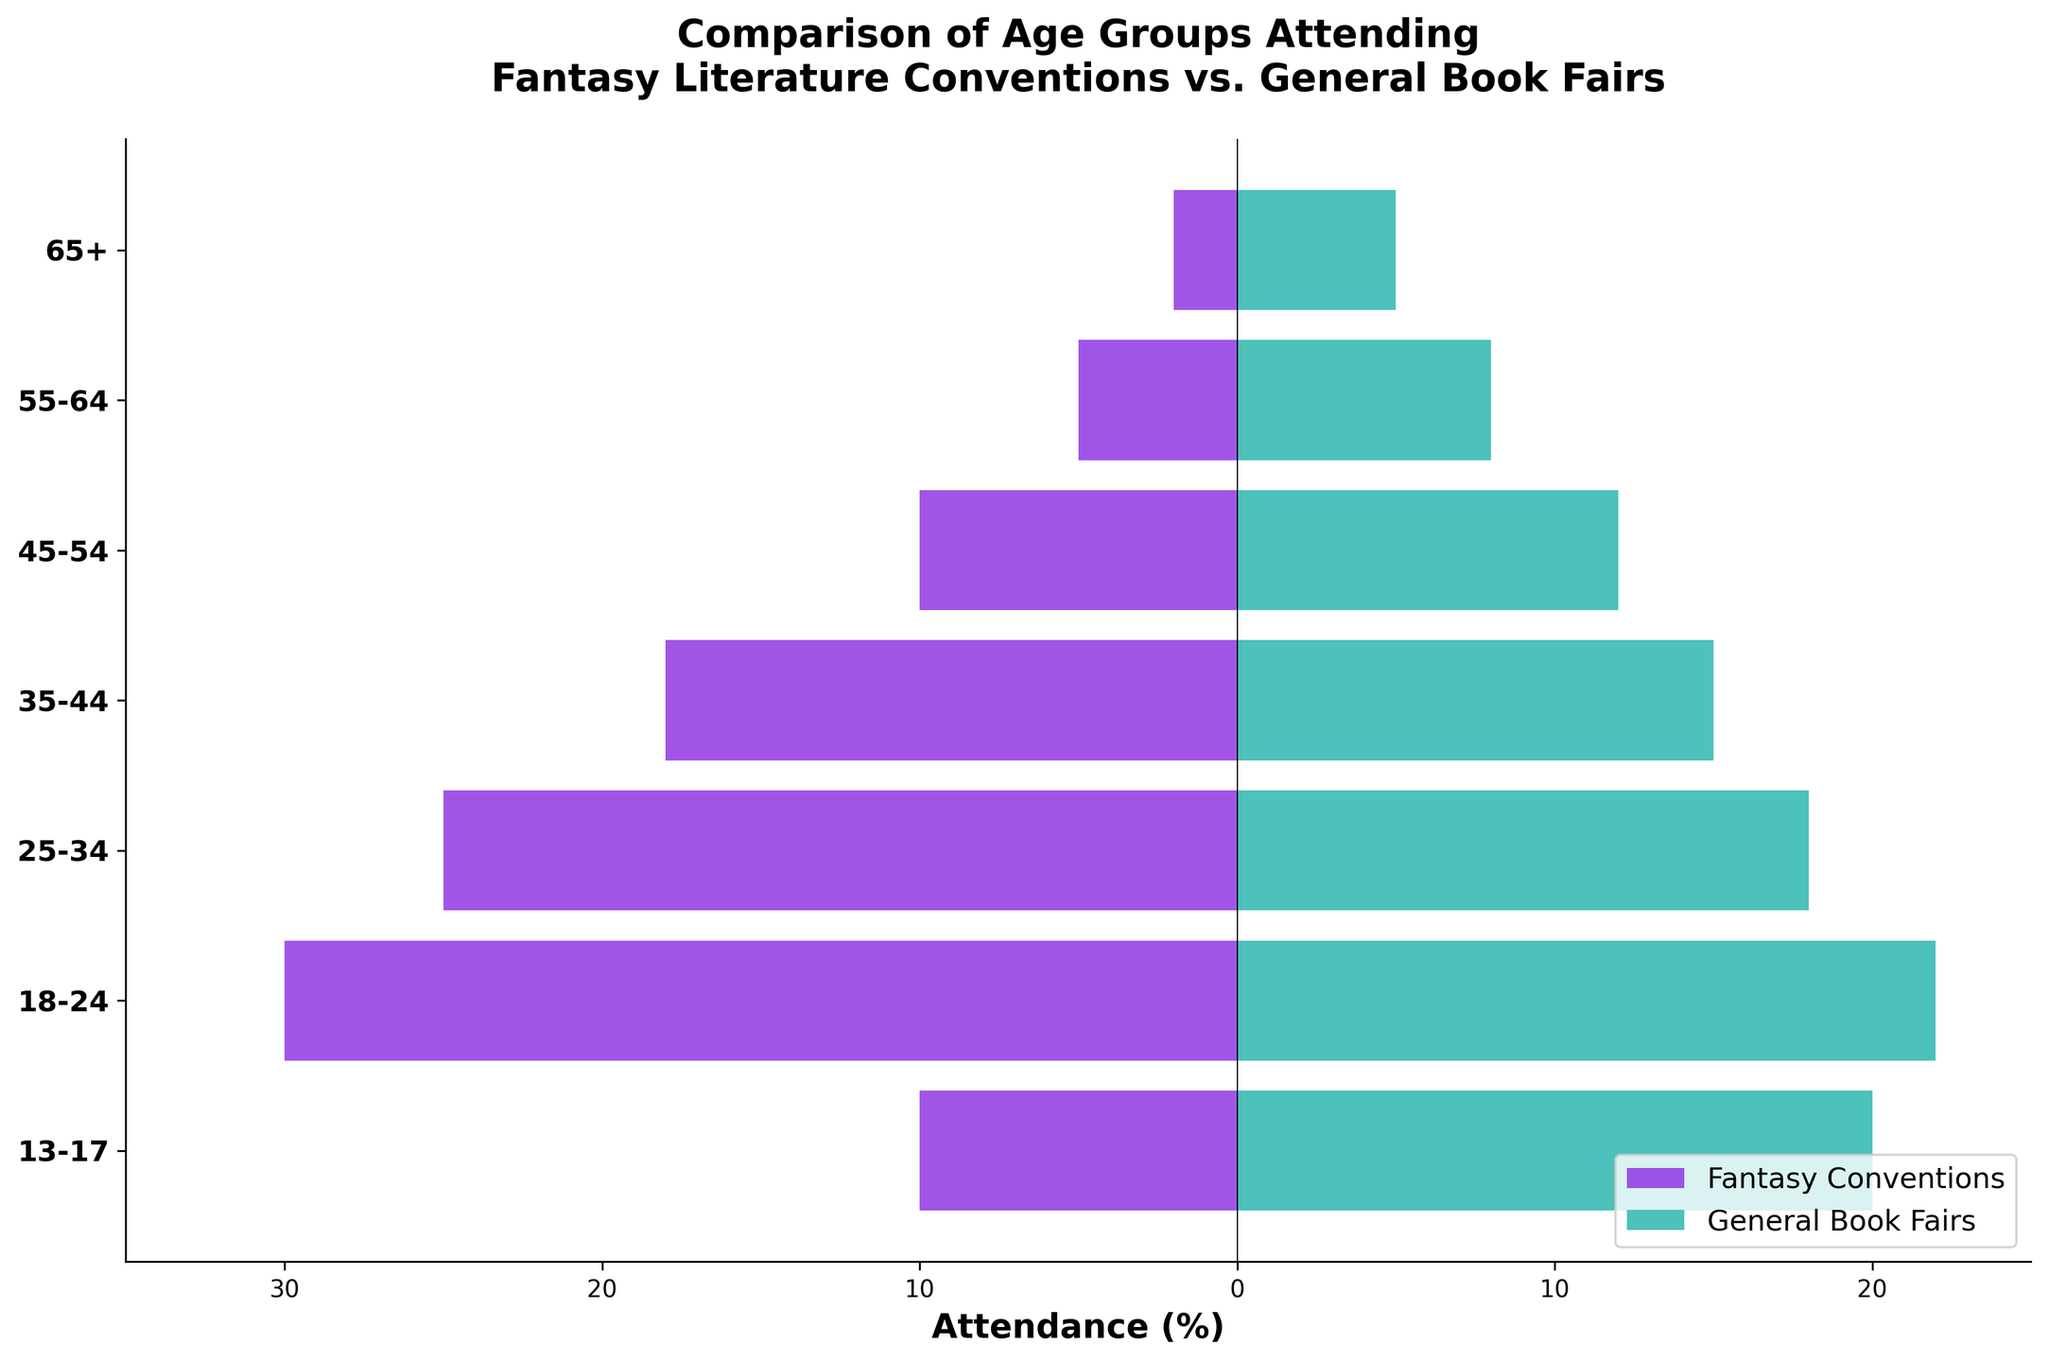What is the title of the figure? The title of the figure is located at the top and is bold. It is "Comparison of Age Groups Attending Fantasy Literature Conventions vs. General Book Fairs".
Answer: Comparison of Age Groups Attending Fantasy Literature Conventions vs. General Book Fairs Which age group has the highest attendance percentage at fantasy conventions? By looking at the bars in the figure, the largest negative value on the fantasy conventions side (purple bars) is for the 18-24 age group.
Answer: 18-24 What is the attendance percentage for the 13-17 age group at general book fairs? Look at the bar corresponding to the 13-17 age group and check the value for the general book fairs side (teal bars). The number is 20.
Answer: 20 Which age group shows the highest attendance for general book fairs? Find the bar with the largest positive value on the general book fairs side (teal bars). The highest value is for the 18-24 age group.
Answer: 18-24 How much higher is the attendance percentage for the 35-44 age group at general book fairs compared to fantasy conventions? The bar for the 35-44 age group shows -18 for fantasy conventions and 15 for general book fairs. The difference is 15 - (-18) = 33.
Answer: 33 Which event has a higher attendance in the 65+ age group, and by how much? Compare the values of the 65+ age group for both events. Fantasy conventions have -2, and general book fairs have 5. General book fairs have a higher attendance by 5 - (-2) = 7.
Answer: General book fairs by 7 What is the range of the x-axis in the figure? The x-axis of the figure ranges from -35 to 25, as seen from the labels and the axis limits.
Answer: -35 to 25 Calculate the total difference in attendance percentages between the events for the 25-34 age group. The bar for the 25-34 age group is -25 for fantasy conventions and 18 for general book fairs. The total difference is 25 + 18 = 43.
Answer: 43 Which age group has almost equal attendance percentages for both events? Examine the bars for each age group, looking for bars that are closely equal in length on both sides. The 13-17 age group shows values of -10 and 20, which are not equal. The closest is the 65+ age group with -2 and 5.
Answer: 65+ How do attendance percentages for fantasy conventions compare to general book fairs for the 45-54 age group? The bar for the 45-54 age group is -10 for fantasy conventions and 12 for general book fairs. General book fairs have higher attendance than fantasy conventions by 12 - (-10) = 22.
Answer: General book fairs have higher attendance by 22 